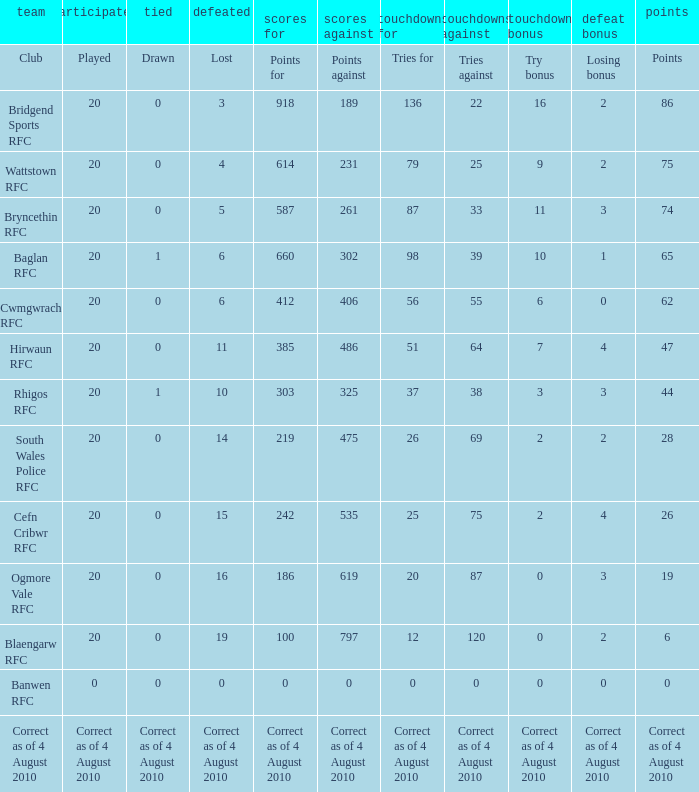What is the points against when the losing bonus is 0 and the club is banwen rfc? 0.0. 